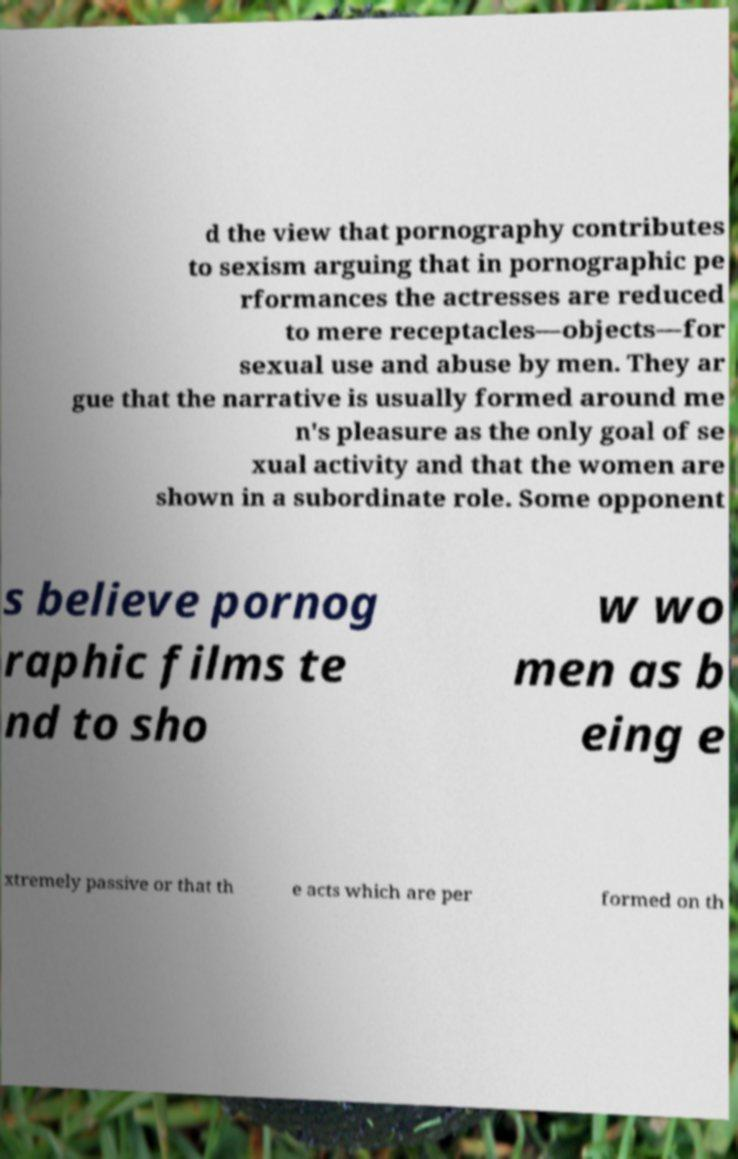For documentation purposes, I need the text within this image transcribed. Could you provide that? d the view that pornography contributes to sexism arguing that in pornographic pe rformances the actresses are reduced to mere receptacles—objects—for sexual use and abuse by men. They ar gue that the narrative is usually formed around me n's pleasure as the only goal of se xual activity and that the women are shown in a subordinate role. Some opponent s believe pornog raphic films te nd to sho w wo men as b eing e xtremely passive or that th e acts which are per formed on th 